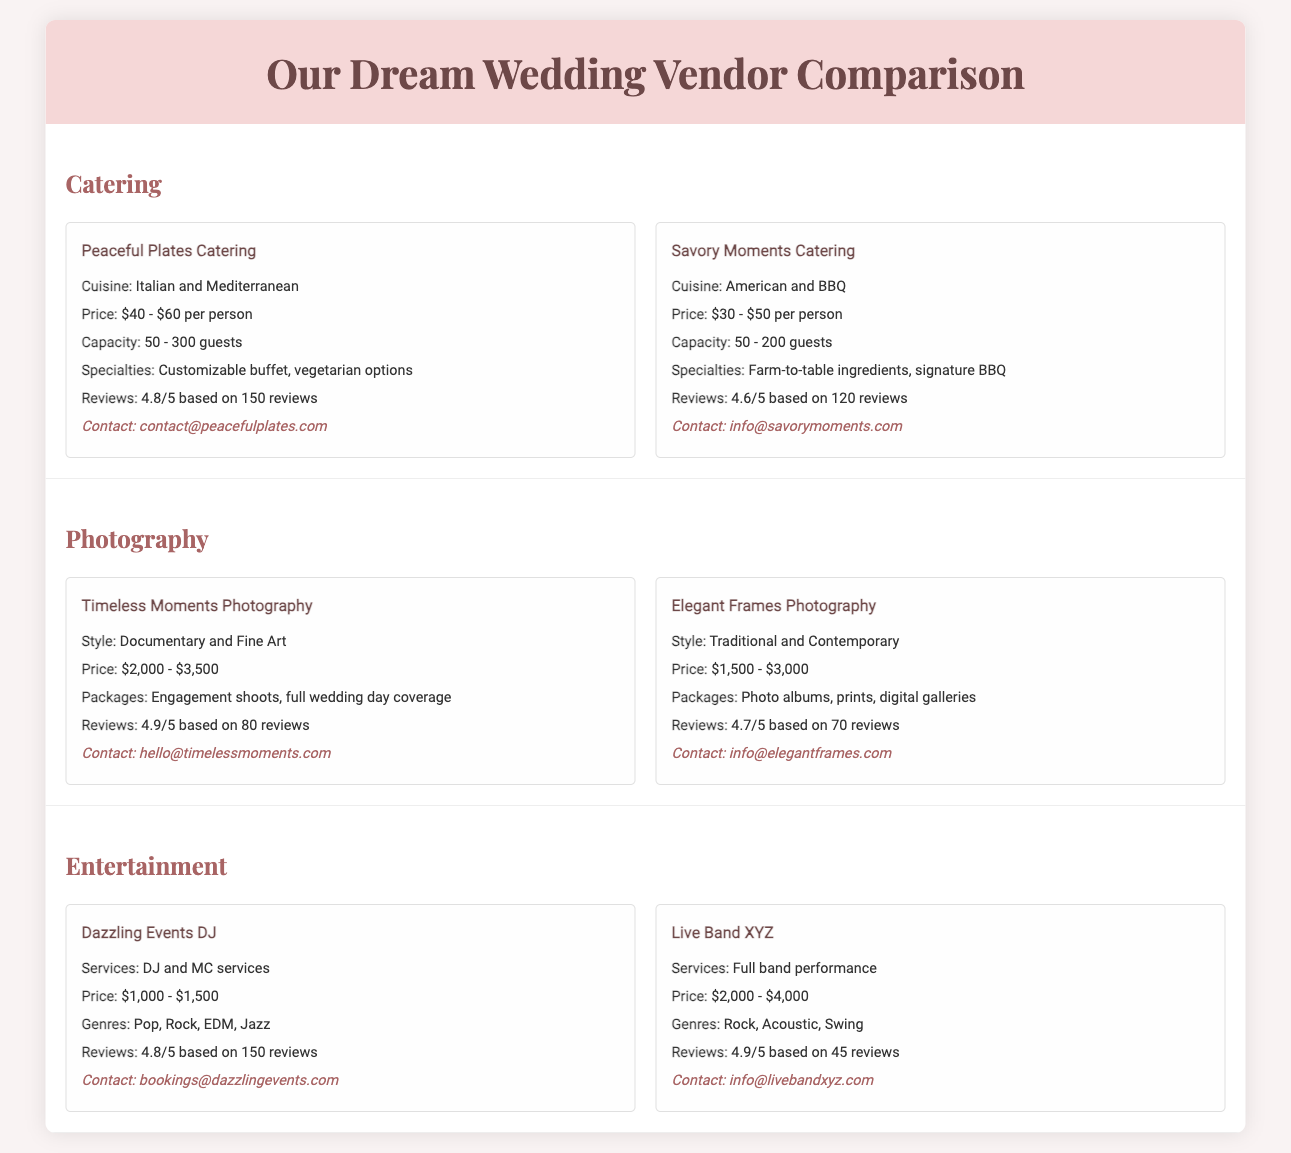What is the price range for Peaceful Plates Catering? The price range for Peaceful Plates Catering is listed in the document as $40 - $60 per person.
Answer: $40 - $60 per person How many guests can Savory Moments Catering accommodate? The capacity of Savory Moments Catering is mentioned as 50 - 200 guests in the document.
Answer: 50 - 200 guests What is the highest rating for any photography vendor? The highest rating is provided for Timeless Moments Photography, which is 4.9/5.
Answer: 4.9/5 What is the contact email for Live Band XYZ? The document provides the contact email for Live Band XYZ as info@livebandxyz.com.
Answer: info@livebandxyz.com What specialties does Peaceful Plates Catering offer? The document states that Peaceful Plates Catering offers a customizable buffet and vegetarian options as specialties.
Answer: Customizable buffet, vegetarian options Which photography vendor offers engagement shoots? Timeless Moments Photography offers engagement shoots as part of their packages, according to the document.
Answer: Timeless Moments Photography What genres does Dazzling Events DJ cover? The document lists the genres covered by Dazzling Events DJ as Pop, Rock, EDM, and Jazz.
Answer: Pop, Rock, EDM, Jazz Which vendor has the most reviews? The document indicates that Dazzling Events DJ has the most reviews, with a total of 150 reviews.
Answer: Dazzling Events DJ What is the price range for Elegant Frames Photography? The price range for Elegant Frames Photography is mentioned as $1,500 - $3,000 in the document.
Answer: $1,500 - $3,000 